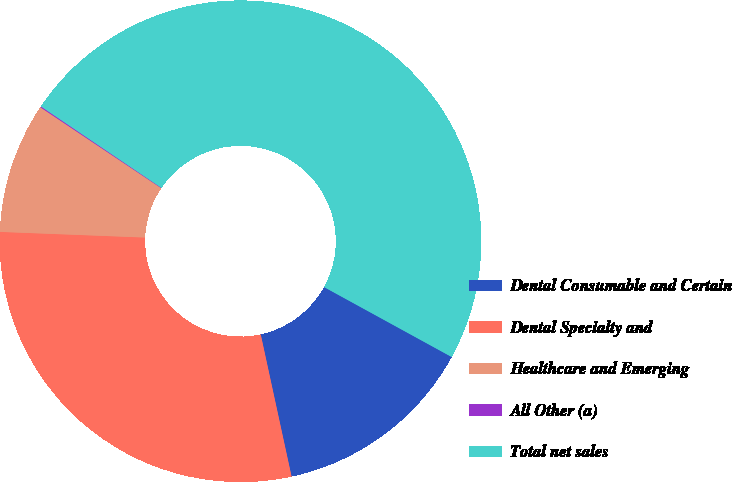Convert chart to OTSL. <chart><loc_0><loc_0><loc_500><loc_500><pie_chart><fcel>Dental Consumable and Certain<fcel>Dental Specialty and<fcel>Healthcare and Emerging<fcel>All Other (a)<fcel>Total net sales<nl><fcel>13.62%<fcel>29.02%<fcel>8.77%<fcel>0.07%<fcel>48.52%<nl></chart> 